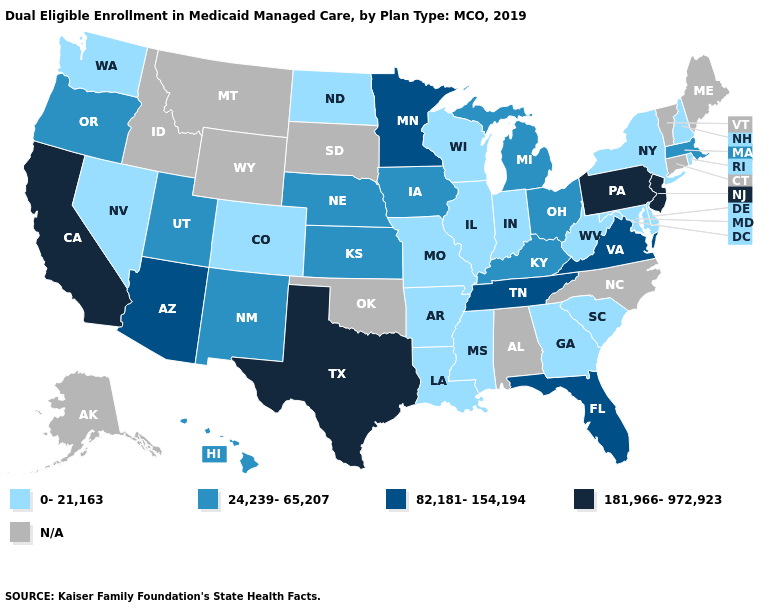Which states hav the highest value in the Northeast?
Keep it brief. New Jersey, Pennsylvania. How many symbols are there in the legend?
Be succinct. 5. What is the value of Hawaii?
Be succinct. 24,239-65,207. Name the states that have a value in the range 181,966-972,923?
Be succinct. California, New Jersey, Pennsylvania, Texas. Name the states that have a value in the range N/A?
Give a very brief answer. Alabama, Alaska, Connecticut, Idaho, Maine, Montana, North Carolina, Oklahoma, South Dakota, Vermont, Wyoming. What is the lowest value in the USA?
Quick response, please. 0-21,163. Does the first symbol in the legend represent the smallest category?
Give a very brief answer. Yes. Among the states that border Maryland , does Virginia have the highest value?
Write a very short answer. No. What is the value of New Jersey?
Give a very brief answer. 181,966-972,923. What is the value of Delaware?
Concise answer only. 0-21,163. What is the value of Maine?
Be succinct. N/A. What is the lowest value in the West?
Quick response, please. 0-21,163. Name the states that have a value in the range N/A?
Answer briefly. Alabama, Alaska, Connecticut, Idaho, Maine, Montana, North Carolina, Oklahoma, South Dakota, Vermont, Wyoming. Which states have the lowest value in the West?
Be succinct. Colorado, Nevada, Washington. What is the highest value in states that border Colorado?
Answer briefly. 82,181-154,194. 